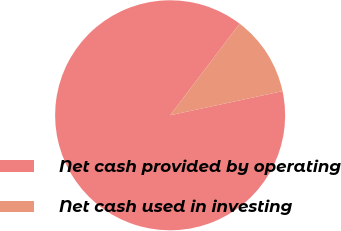Convert chart to OTSL. <chart><loc_0><loc_0><loc_500><loc_500><pie_chart><fcel>Net cash provided by operating<fcel>Net cash used in investing<nl><fcel>88.7%<fcel>11.3%<nl></chart> 